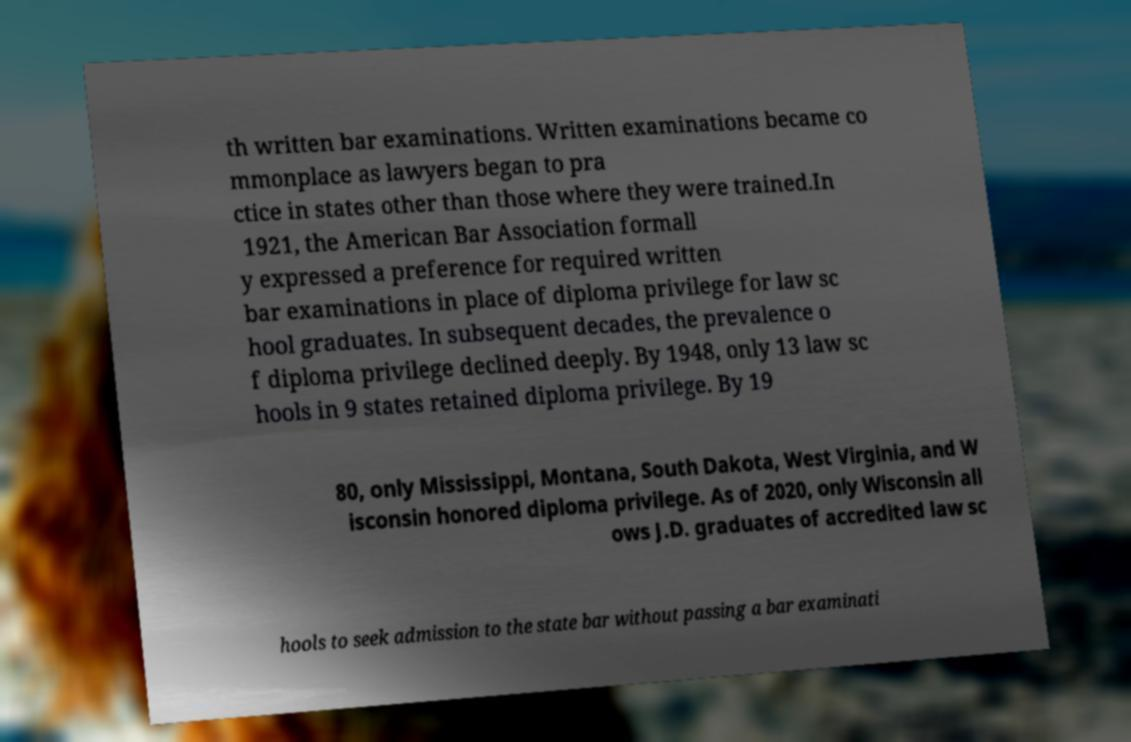Can you read and provide the text displayed in the image?This photo seems to have some interesting text. Can you extract and type it out for me? th written bar examinations. Written examinations became co mmonplace as lawyers began to pra ctice in states other than those where they were trained.In 1921, the American Bar Association formall y expressed a preference for required written bar examinations in place of diploma privilege for law sc hool graduates. In subsequent decades, the prevalence o f diploma privilege declined deeply. By 1948, only 13 law sc hools in 9 states retained diploma privilege. By 19 80, only Mississippi, Montana, South Dakota, West Virginia, and W isconsin honored diploma privilege. As of 2020, only Wisconsin all ows J.D. graduates of accredited law sc hools to seek admission to the state bar without passing a bar examinati 